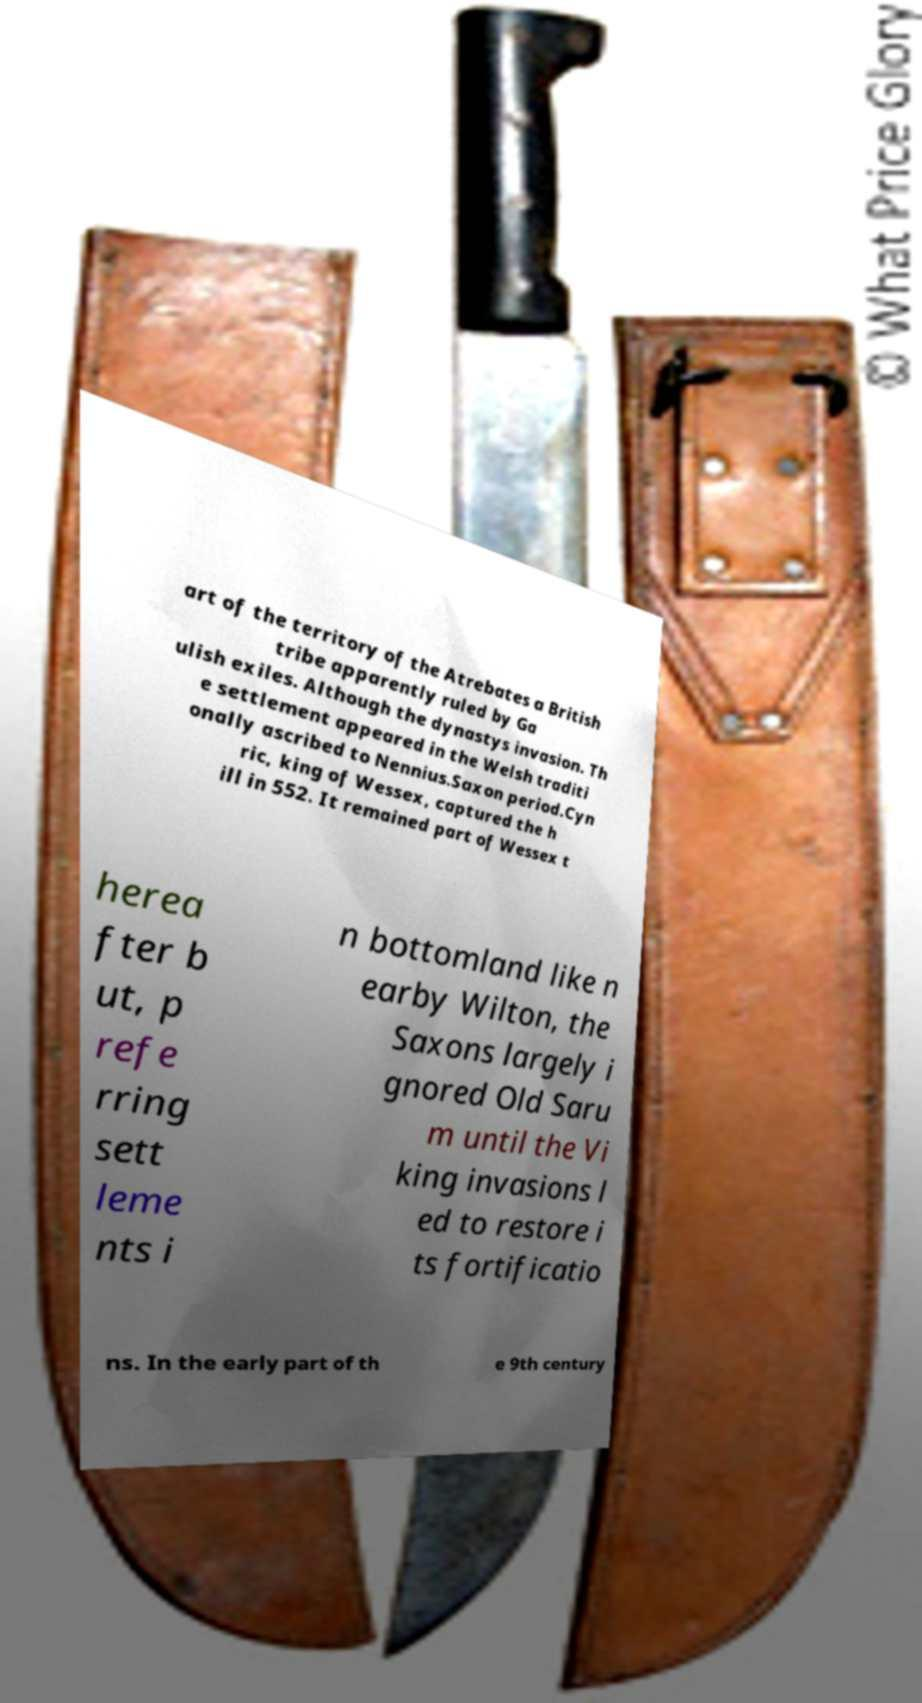Can you read and provide the text displayed in the image?This photo seems to have some interesting text. Can you extract and type it out for me? art of the territory of the Atrebates a British tribe apparently ruled by Ga ulish exiles. Although the dynastys invasion. Th e settlement appeared in the Welsh traditi onally ascribed to Nennius.Saxon period.Cyn ric, king of Wessex, captured the h ill in 552. It remained part of Wessex t herea fter b ut, p refe rring sett leme nts i n bottomland like n earby Wilton, the Saxons largely i gnored Old Saru m until the Vi king invasions l ed to restore i ts fortificatio ns. In the early part of th e 9th century 